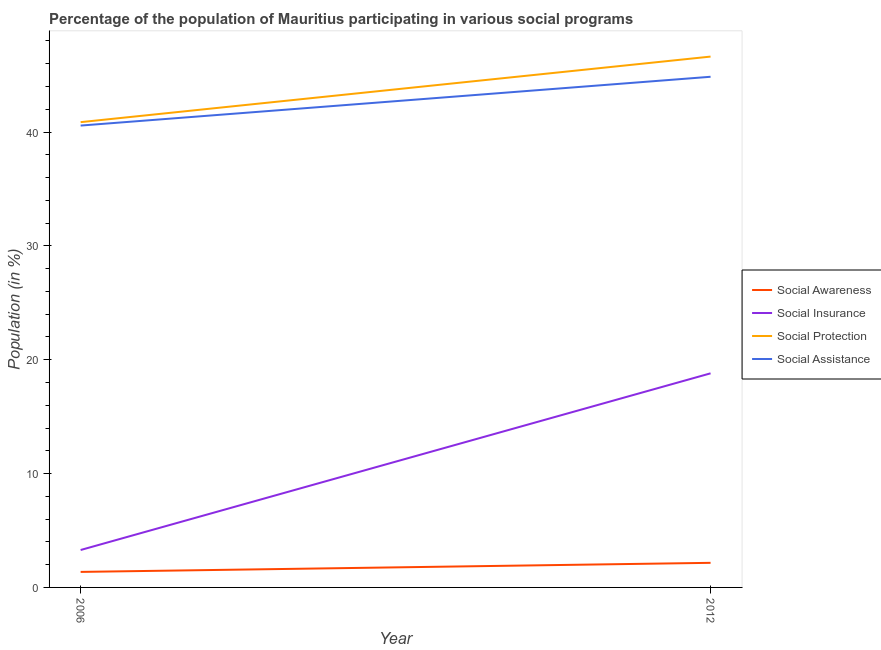Is the number of lines equal to the number of legend labels?
Your answer should be very brief. Yes. What is the participation of population in social insurance programs in 2006?
Make the answer very short. 3.29. Across all years, what is the maximum participation of population in social insurance programs?
Ensure brevity in your answer.  18.8. Across all years, what is the minimum participation of population in social awareness programs?
Offer a very short reply. 1.36. In which year was the participation of population in social assistance programs maximum?
Your answer should be compact. 2012. What is the total participation of population in social awareness programs in the graph?
Provide a short and direct response. 3.52. What is the difference between the participation of population in social insurance programs in 2006 and that in 2012?
Your answer should be very brief. -15.52. What is the difference between the participation of population in social awareness programs in 2012 and the participation of population in social insurance programs in 2006?
Make the answer very short. -1.13. What is the average participation of population in social protection programs per year?
Your answer should be very brief. 43.75. In the year 2012, what is the difference between the participation of population in social insurance programs and participation of population in social assistance programs?
Offer a terse response. -26.05. What is the ratio of the participation of population in social protection programs in 2006 to that in 2012?
Keep it short and to the point. 0.88. In how many years, is the participation of population in social assistance programs greater than the average participation of population in social assistance programs taken over all years?
Your answer should be compact. 1. Is it the case that in every year, the sum of the participation of population in social awareness programs and participation of population in social insurance programs is greater than the participation of population in social protection programs?
Give a very brief answer. No. Does the participation of population in social insurance programs monotonically increase over the years?
Your answer should be compact. Yes. Is the participation of population in social protection programs strictly less than the participation of population in social awareness programs over the years?
Offer a very short reply. No. How many lines are there?
Provide a succinct answer. 4. How many years are there in the graph?
Give a very brief answer. 2. Are the values on the major ticks of Y-axis written in scientific E-notation?
Keep it short and to the point. No. How many legend labels are there?
Keep it short and to the point. 4. How are the legend labels stacked?
Keep it short and to the point. Vertical. What is the title of the graph?
Make the answer very short. Percentage of the population of Mauritius participating in various social programs . What is the label or title of the Y-axis?
Offer a very short reply. Population (in %). What is the Population (in %) of Social Awareness in 2006?
Offer a very short reply. 1.36. What is the Population (in %) in Social Insurance in 2006?
Give a very brief answer. 3.29. What is the Population (in %) in Social Protection in 2006?
Provide a succinct answer. 40.87. What is the Population (in %) in Social Assistance in 2006?
Your answer should be compact. 40.57. What is the Population (in %) in Social Awareness in 2012?
Give a very brief answer. 2.16. What is the Population (in %) in Social Insurance in 2012?
Provide a short and direct response. 18.8. What is the Population (in %) in Social Protection in 2012?
Provide a succinct answer. 46.63. What is the Population (in %) in Social Assistance in 2012?
Your answer should be very brief. 44.85. Across all years, what is the maximum Population (in %) of Social Awareness?
Give a very brief answer. 2.16. Across all years, what is the maximum Population (in %) in Social Insurance?
Give a very brief answer. 18.8. Across all years, what is the maximum Population (in %) in Social Protection?
Provide a short and direct response. 46.63. Across all years, what is the maximum Population (in %) in Social Assistance?
Make the answer very short. 44.85. Across all years, what is the minimum Population (in %) in Social Awareness?
Make the answer very short. 1.36. Across all years, what is the minimum Population (in %) in Social Insurance?
Provide a short and direct response. 3.29. Across all years, what is the minimum Population (in %) of Social Protection?
Your response must be concise. 40.87. Across all years, what is the minimum Population (in %) in Social Assistance?
Your response must be concise. 40.57. What is the total Population (in %) in Social Awareness in the graph?
Ensure brevity in your answer.  3.52. What is the total Population (in %) in Social Insurance in the graph?
Provide a succinct answer. 22.09. What is the total Population (in %) in Social Protection in the graph?
Your answer should be very brief. 87.49. What is the total Population (in %) in Social Assistance in the graph?
Give a very brief answer. 85.42. What is the difference between the Population (in %) in Social Awareness in 2006 and that in 2012?
Provide a succinct answer. -0.8. What is the difference between the Population (in %) in Social Insurance in 2006 and that in 2012?
Offer a very short reply. -15.52. What is the difference between the Population (in %) of Social Protection in 2006 and that in 2012?
Your answer should be very brief. -5.76. What is the difference between the Population (in %) in Social Assistance in 2006 and that in 2012?
Ensure brevity in your answer.  -4.29. What is the difference between the Population (in %) in Social Awareness in 2006 and the Population (in %) in Social Insurance in 2012?
Your answer should be compact. -17.44. What is the difference between the Population (in %) of Social Awareness in 2006 and the Population (in %) of Social Protection in 2012?
Your answer should be compact. -45.26. What is the difference between the Population (in %) of Social Awareness in 2006 and the Population (in %) of Social Assistance in 2012?
Your response must be concise. -43.49. What is the difference between the Population (in %) in Social Insurance in 2006 and the Population (in %) in Social Protection in 2012?
Your answer should be compact. -43.34. What is the difference between the Population (in %) of Social Insurance in 2006 and the Population (in %) of Social Assistance in 2012?
Make the answer very short. -41.57. What is the difference between the Population (in %) in Social Protection in 2006 and the Population (in %) in Social Assistance in 2012?
Keep it short and to the point. -3.99. What is the average Population (in %) in Social Awareness per year?
Offer a very short reply. 1.76. What is the average Population (in %) of Social Insurance per year?
Your answer should be compact. 11.05. What is the average Population (in %) of Social Protection per year?
Ensure brevity in your answer.  43.75. What is the average Population (in %) of Social Assistance per year?
Your response must be concise. 42.71. In the year 2006, what is the difference between the Population (in %) in Social Awareness and Population (in %) in Social Insurance?
Ensure brevity in your answer.  -1.92. In the year 2006, what is the difference between the Population (in %) in Social Awareness and Population (in %) in Social Protection?
Make the answer very short. -39.51. In the year 2006, what is the difference between the Population (in %) of Social Awareness and Population (in %) of Social Assistance?
Keep it short and to the point. -39.2. In the year 2006, what is the difference between the Population (in %) in Social Insurance and Population (in %) in Social Protection?
Offer a terse response. -37.58. In the year 2006, what is the difference between the Population (in %) of Social Insurance and Population (in %) of Social Assistance?
Make the answer very short. -37.28. In the year 2006, what is the difference between the Population (in %) of Social Protection and Population (in %) of Social Assistance?
Offer a terse response. 0.3. In the year 2012, what is the difference between the Population (in %) of Social Awareness and Population (in %) of Social Insurance?
Your answer should be compact. -16.64. In the year 2012, what is the difference between the Population (in %) of Social Awareness and Population (in %) of Social Protection?
Your answer should be compact. -44.47. In the year 2012, what is the difference between the Population (in %) in Social Awareness and Population (in %) in Social Assistance?
Offer a very short reply. -42.69. In the year 2012, what is the difference between the Population (in %) of Social Insurance and Population (in %) of Social Protection?
Ensure brevity in your answer.  -27.82. In the year 2012, what is the difference between the Population (in %) in Social Insurance and Population (in %) in Social Assistance?
Your response must be concise. -26.05. In the year 2012, what is the difference between the Population (in %) in Social Protection and Population (in %) in Social Assistance?
Provide a short and direct response. 1.77. What is the ratio of the Population (in %) of Social Awareness in 2006 to that in 2012?
Offer a terse response. 0.63. What is the ratio of the Population (in %) of Social Insurance in 2006 to that in 2012?
Provide a succinct answer. 0.17. What is the ratio of the Population (in %) of Social Protection in 2006 to that in 2012?
Ensure brevity in your answer.  0.88. What is the ratio of the Population (in %) of Social Assistance in 2006 to that in 2012?
Provide a succinct answer. 0.9. What is the difference between the highest and the second highest Population (in %) in Social Awareness?
Provide a succinct answer. 0.8. What is the difference between the highest and the second highest Population (in %) in Social Insurance?
Keep it short and to the point. 15.52. What is the difference between the highest and the second highest Population (in %) in Social Protection?
Your answer should be very brief. 5.76. What is the difference between the highest and the second highest Population (in %) of Social Assistance?
Ensure brevity in your answer.  4.29. What is the difference between the highest and the lowest Population (in %) in Social Awareness?
Provide a succinct answer. 0.8. What is the difference between the highest and the lowest Population (in %) in Social Insurance?
Offer a terse response. 15.52. What is the difference between the highest and the lowest Population (in %) in Social Protection?
Give a very brief answer. 5.76. What is the difference between the highest and the lowest Population (in %) of Social Assistance?
Provide a succinct answer. 4.29. 